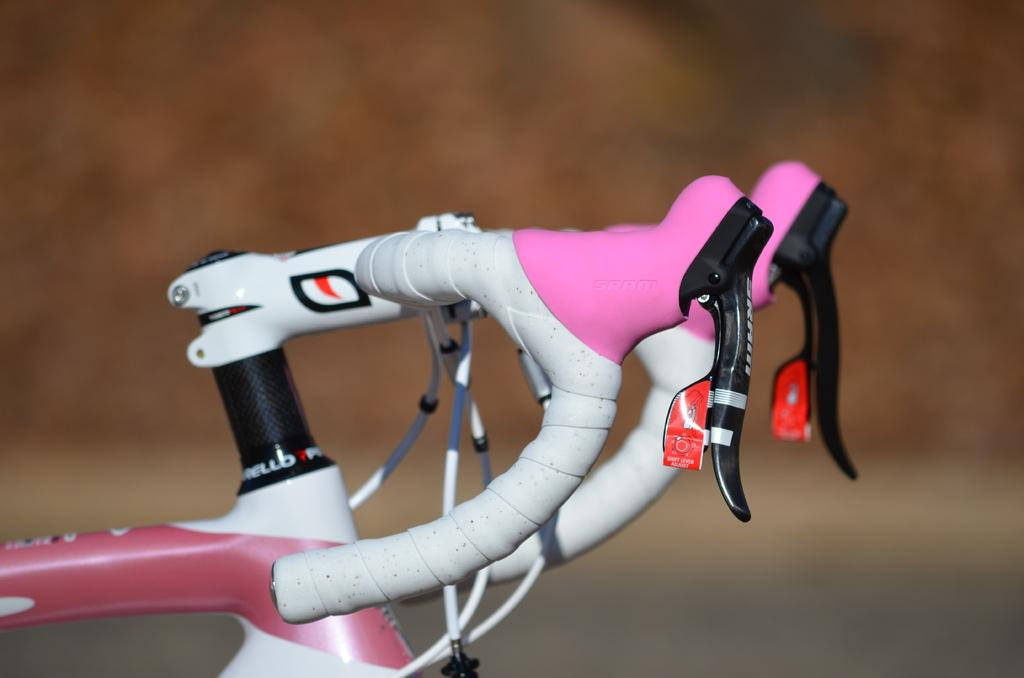What part of a bicycle is visible in the image? There is a bicycle handle in the image. What feature does the bicycle handle have? The bicycle handle has gears. Can you describe the background of the image? The background of the image is blurred. What type of apparatus is being offered to the person in the image? There is no person present in the image, and no apparatus is being offered. 